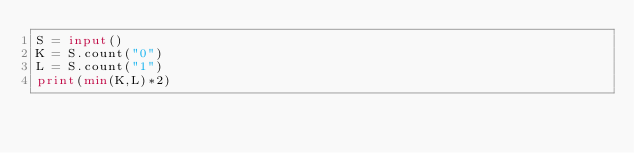<code> <loc_0><loc_0><loc_500><loc_500><_Python_>S = input()
K = S.count("0")
L = S.count("1")
print(min(K,L)*2)</code> 